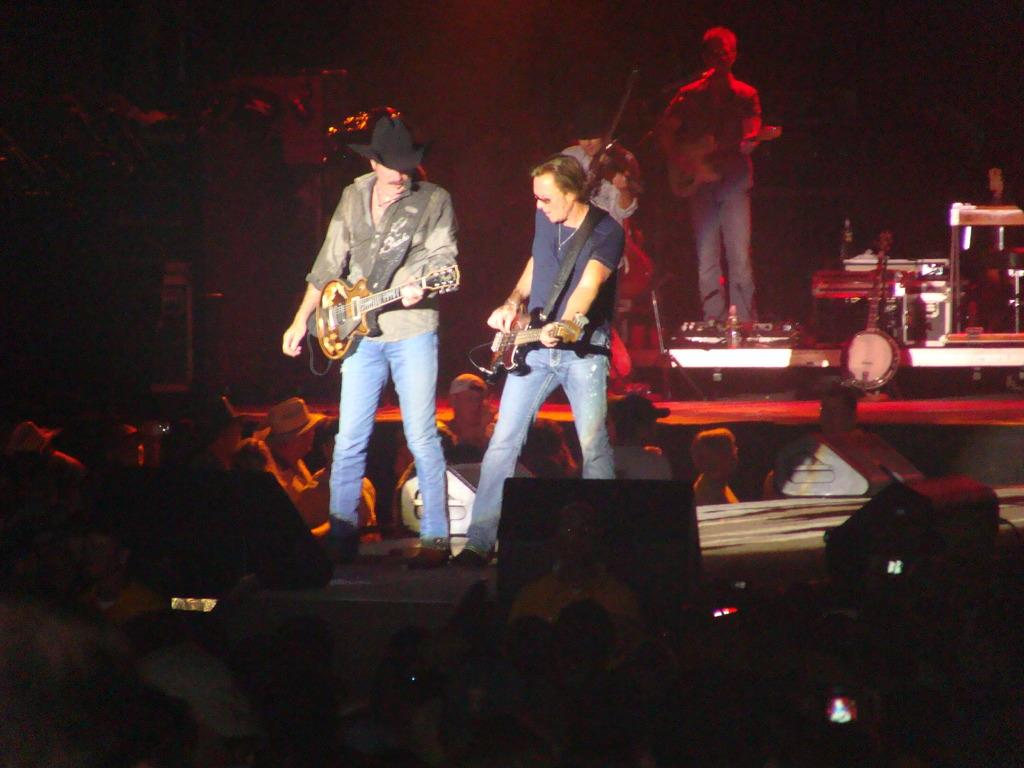What type of event is happening in the image? A musical concert is taking place. What instruments are being played on the stage? People are playing guitar on the stage. Are there any other instruments present on the stage? Yes, there are other instruments on the stage. What can be observed about the audience in the image? People are standing in front of the stage. Can you tell me how many legs the snail has in the image? There is no snail present in the image. What type of self-portrait is being created by the musicians on stage? The image does not depict any self-portraits being created by the musicians; they are playing instruments during a musical concert. 